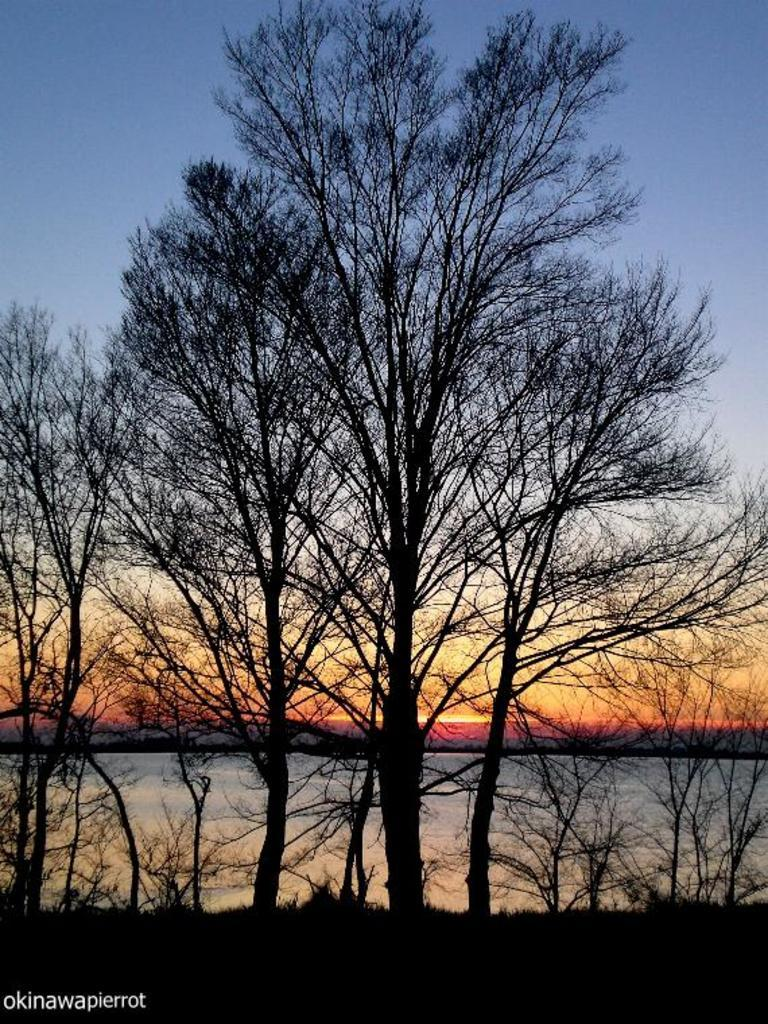What is the primary feature of the image? There are many trees in the image. What can be seen in the background of the image? The sky is visible in the background of the image. Is there any text or marking at the bottom of the image? Yes, there is a watermark at the bottom of the image. How many coils can be seen in the image? There are no coils present in the image; it primarily features trees and the sky. What type of leaf is depicted on the trees in the image? The image does not show specific leaves on the trees; it only shows the overall shape and structure of the trees. 